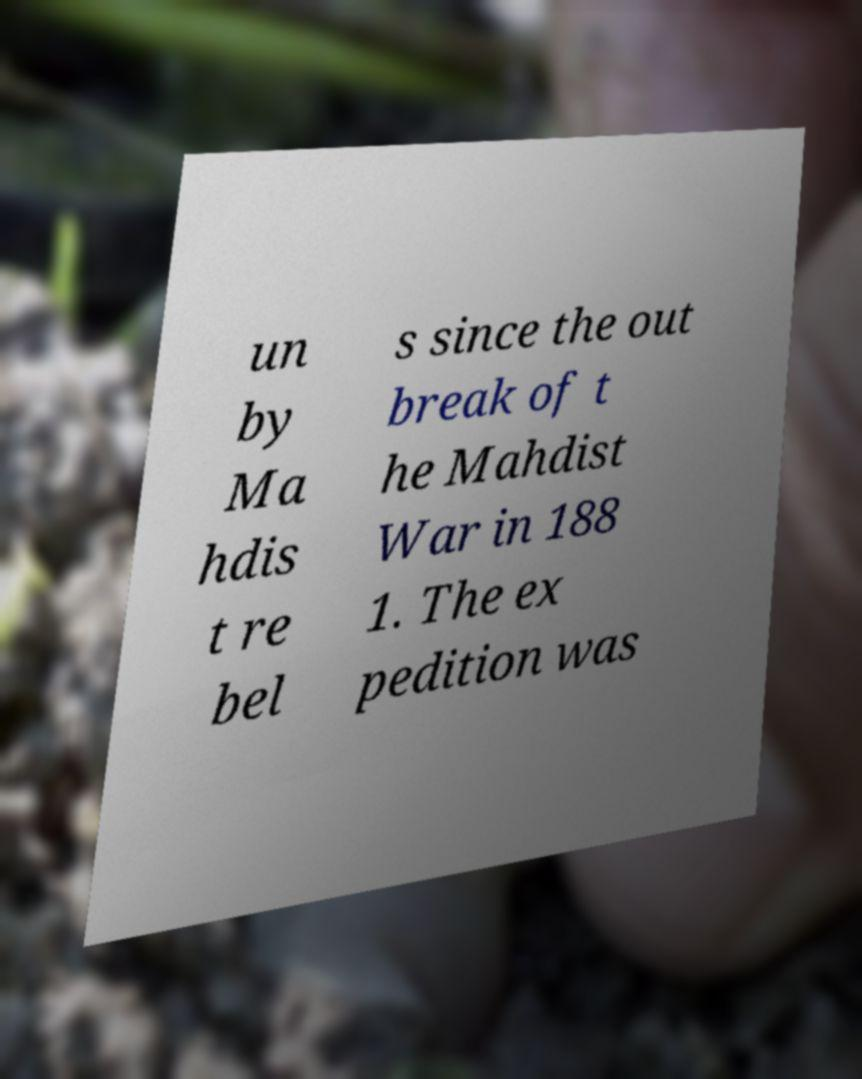Please identify and transcribe the text found in this image. un by Ma hdis t re bel s since the out break of t he Mahdist War in 188 1. The ex pedition was 